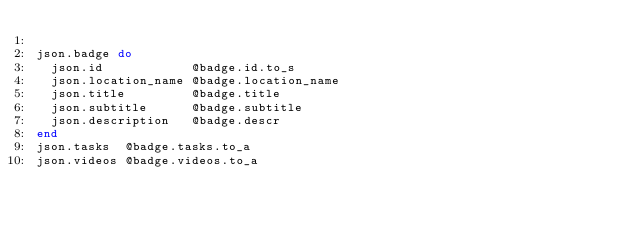<code> <loc_0><loc_0><loc_500><loc_500><_Ruby_>
json.badge do
  json.id            @badge.id.to_s
  json.location_name @badge.location_name
  json.title         @badge.title
  json.subtitle      @badge.subtitle
  json.description   @badge.descr
end
json.tasks  @badge.tasks.to_a
json.videos @badge.videos.to_a


</code> 